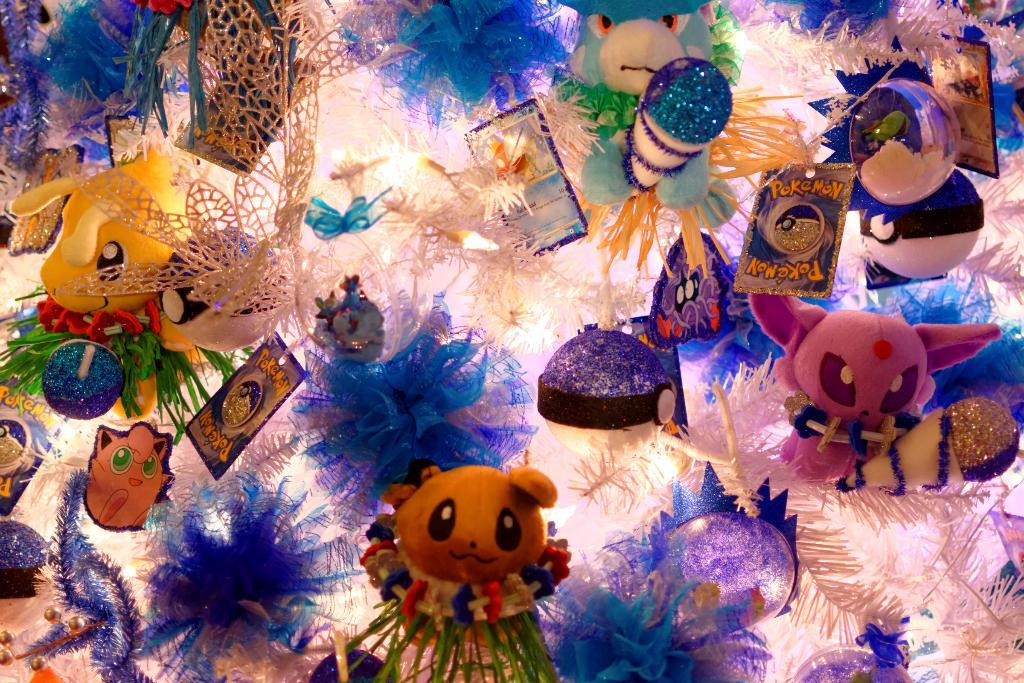What type of objects can be seen in the image? There are many toys in the image. Is there a river flowing through the toys in the image? There is no river present in the image; it only features many toys. What type of object is used to protect oneself from the rain, and is it visible in the image? There is no umbrella visible in the image; it only features many toys. 